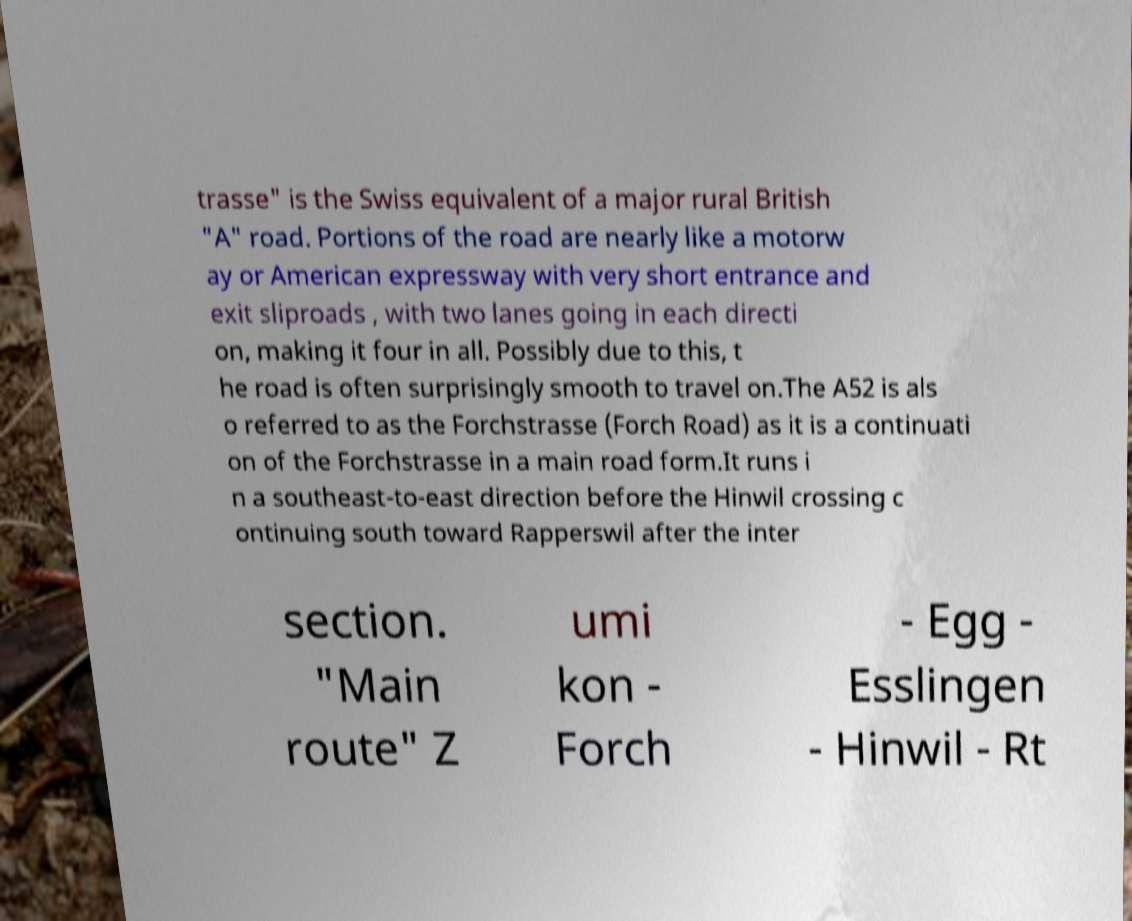What messages or text are displayed in this image? I need them in a readable, typed format. trasse" is the Swiss equivalent of a major rural British "A" road. Portions of the road are nearly like a motorw ay or American expressway with very short entrance and exit sliproads , with two lanes going in each directi on, making it four in all. Possibly due to this, t he road is often surprisingly smooth to travel on.The A52 is als o referred to as the Forchstrasse (Forch Road) as it is a continuati on of the Forchstrasse in a main road form.It runs i n a southeast-to-east direction before the Hinwil crossing c ontinuing south toward Rapperswil after the inter section. "Main route" Z umi kon - Forch - Egg - Esslingen - Hinwil - Rt 